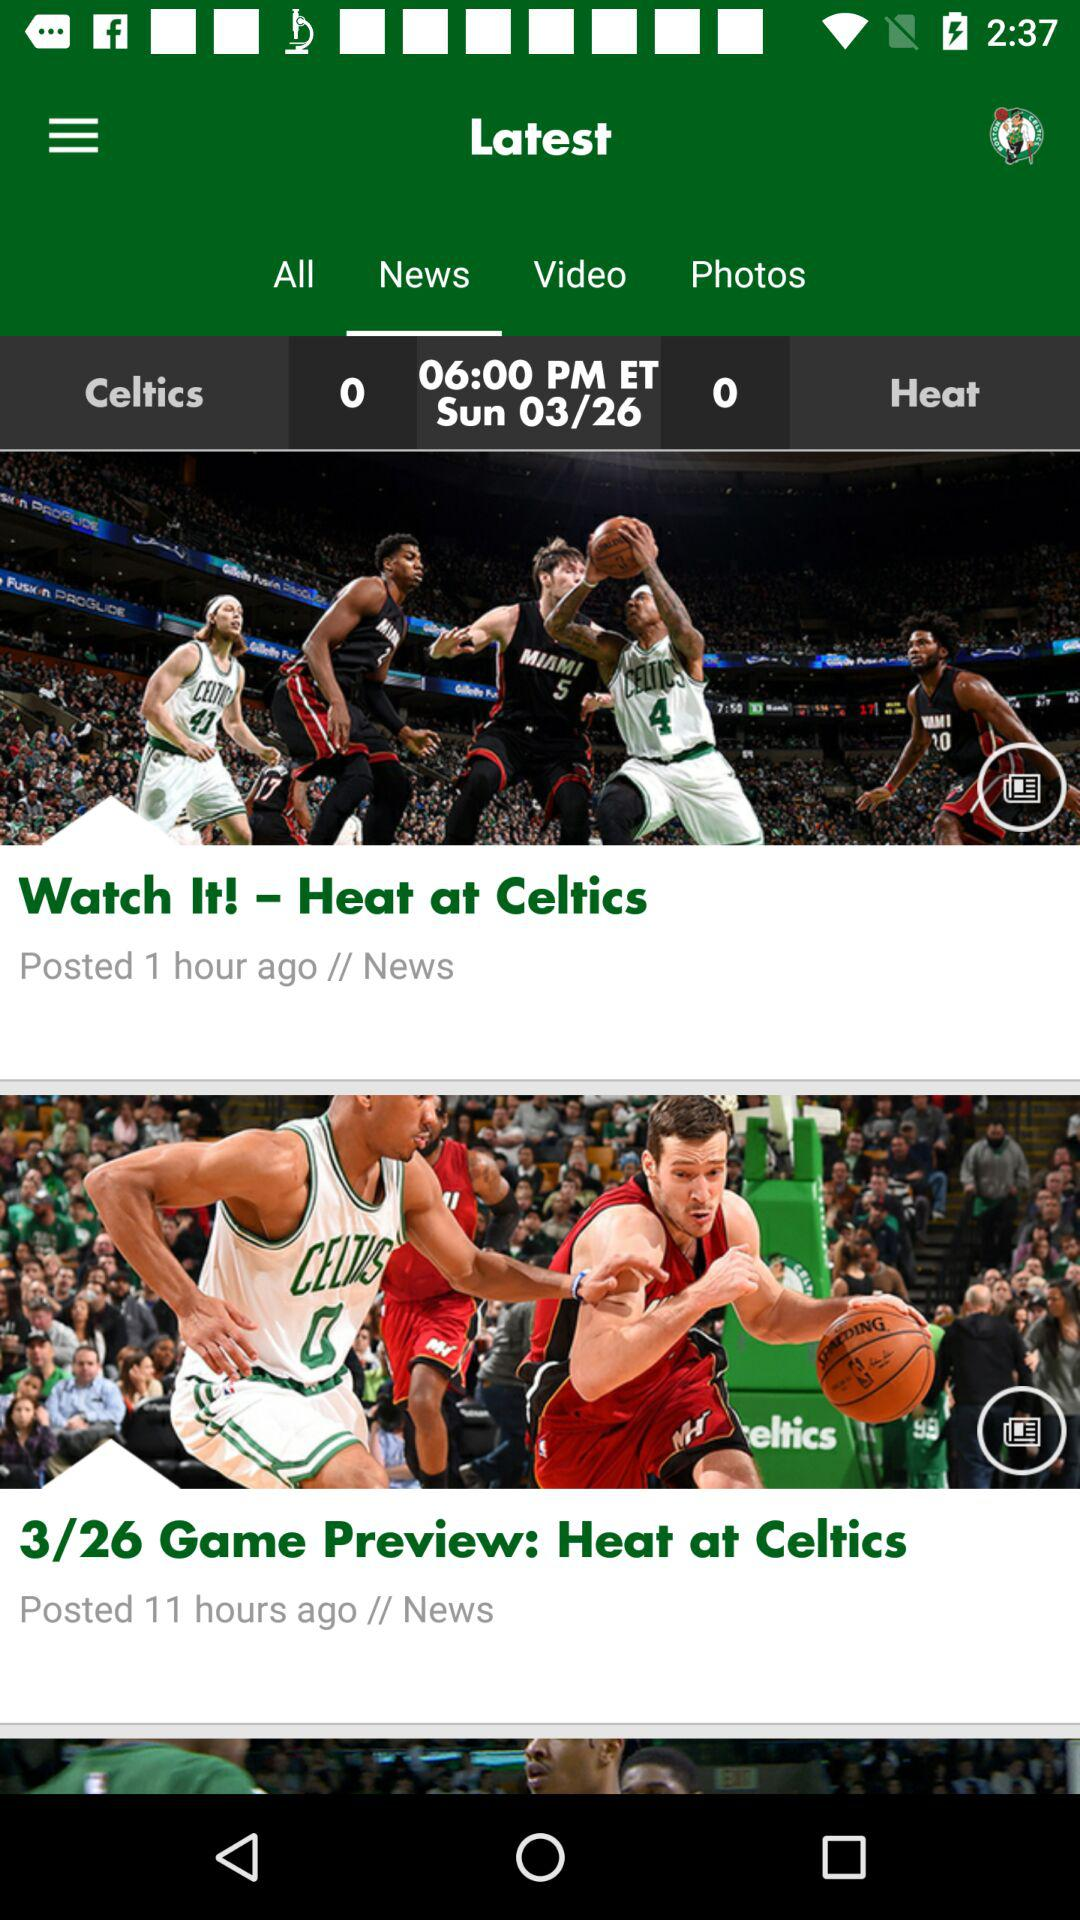How many hours ago was the news with the title "3/26 Game Preview: Heat at Celtics" posted? The news was posted 11 hours ago. 